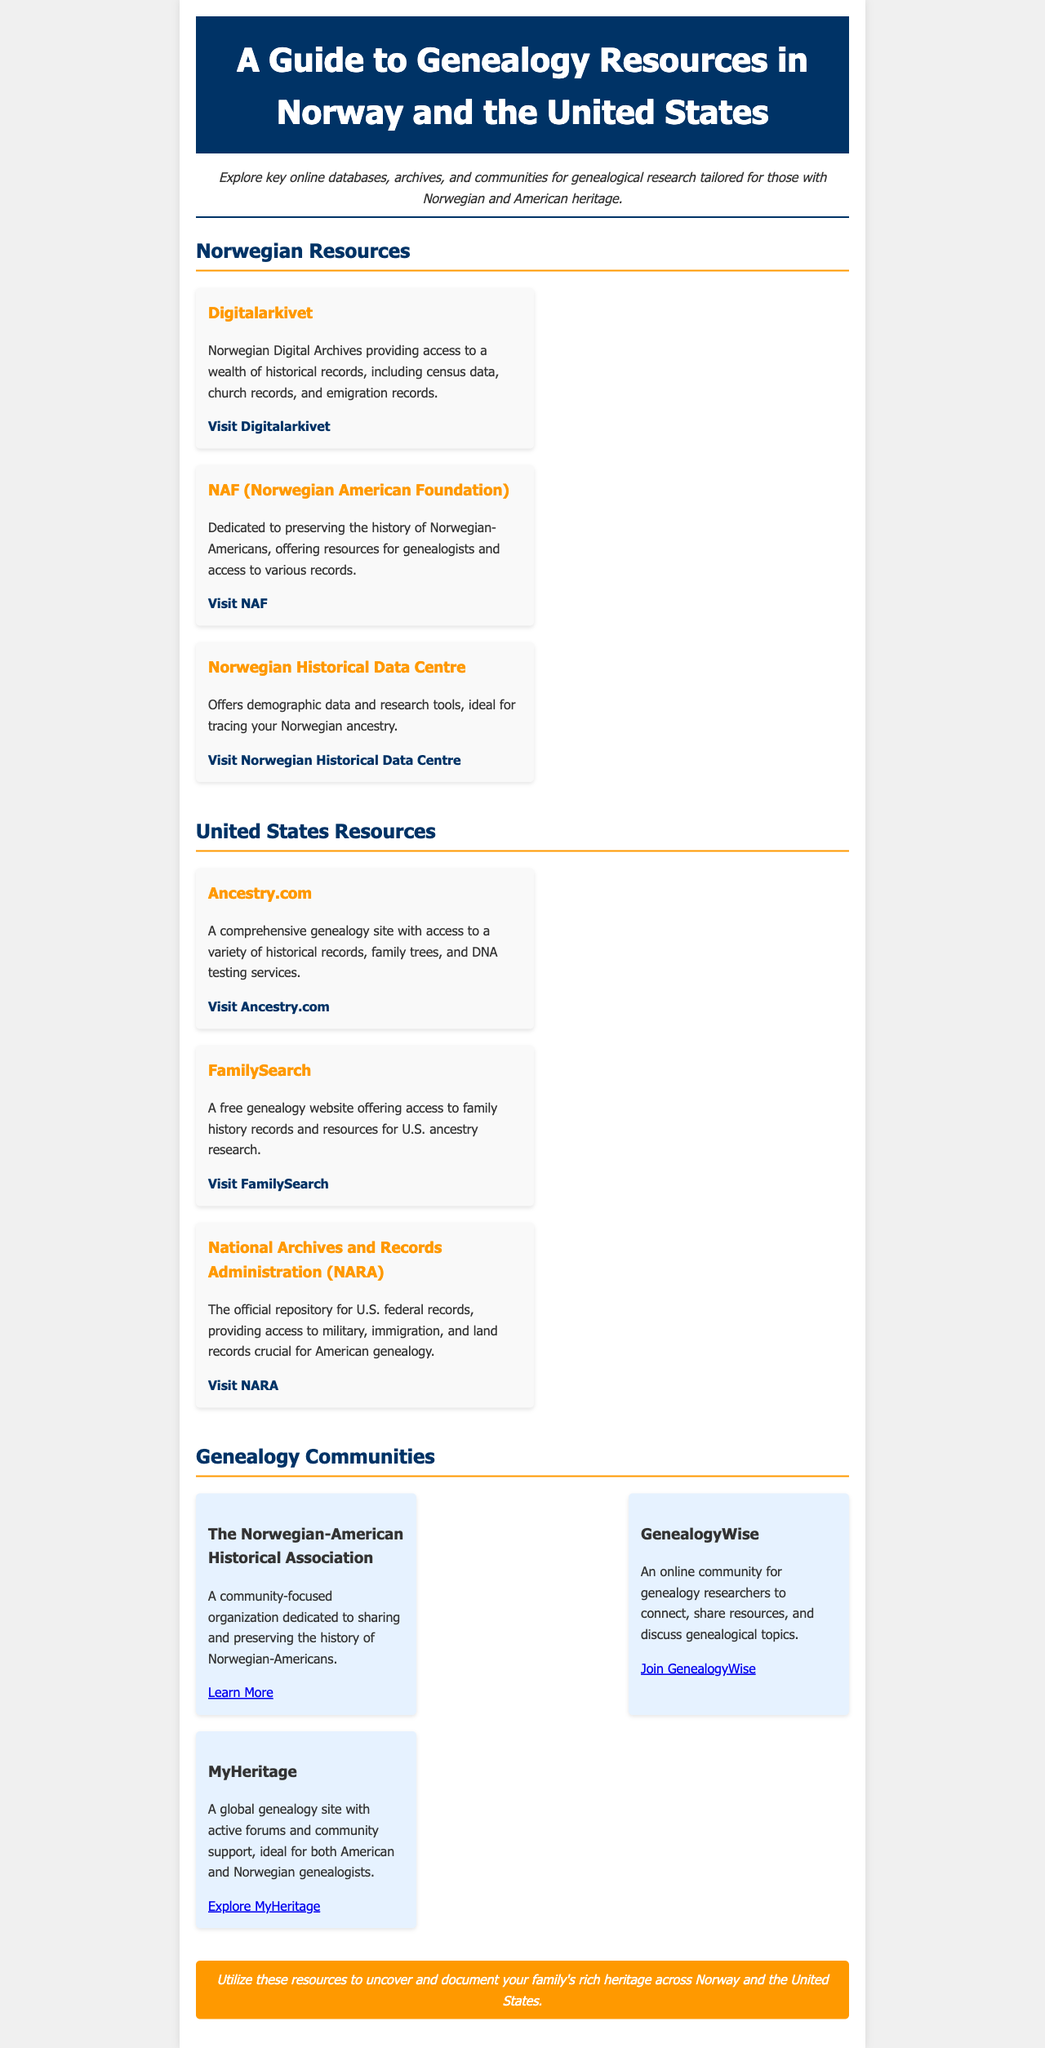what is the title of the newsletter? The title is provided in the header section of the document.
Answer: A Guide to Genealogy Resources in Norway and the United States how many Norwegian resources are listed? The document lists three specific resources under the Norwegian Resources section.
Answer: 3 which community organization focuses on Norwegian-Americans? The document explicitly names a community organization dedicated to Norwegian-American history.
Answer: The Norwegian-American Historical Association what type of records can be accessed at NARA? The document mentions the types of records available at the National Archives and Records Administration.
Answer: Military, immigration, and land records what is the website for FamilySearch? The document provides the URL for FamilySearch among the resources listed for U.S. ancestry research.
Answer: https://www.familysearch.org/ which resource provides access to historical records including census data? The document specifies a Norwegian resource that offers various historical records.
Answer: Digitalarkivet how many community-focused organizations are mentioned? The document lists three community organizations in the Genealogy Communities section.
Answer: 3 what color is used for the headings in the resource items? The document describes the color scheme used for headings and items within the content.
Answer: #003366 